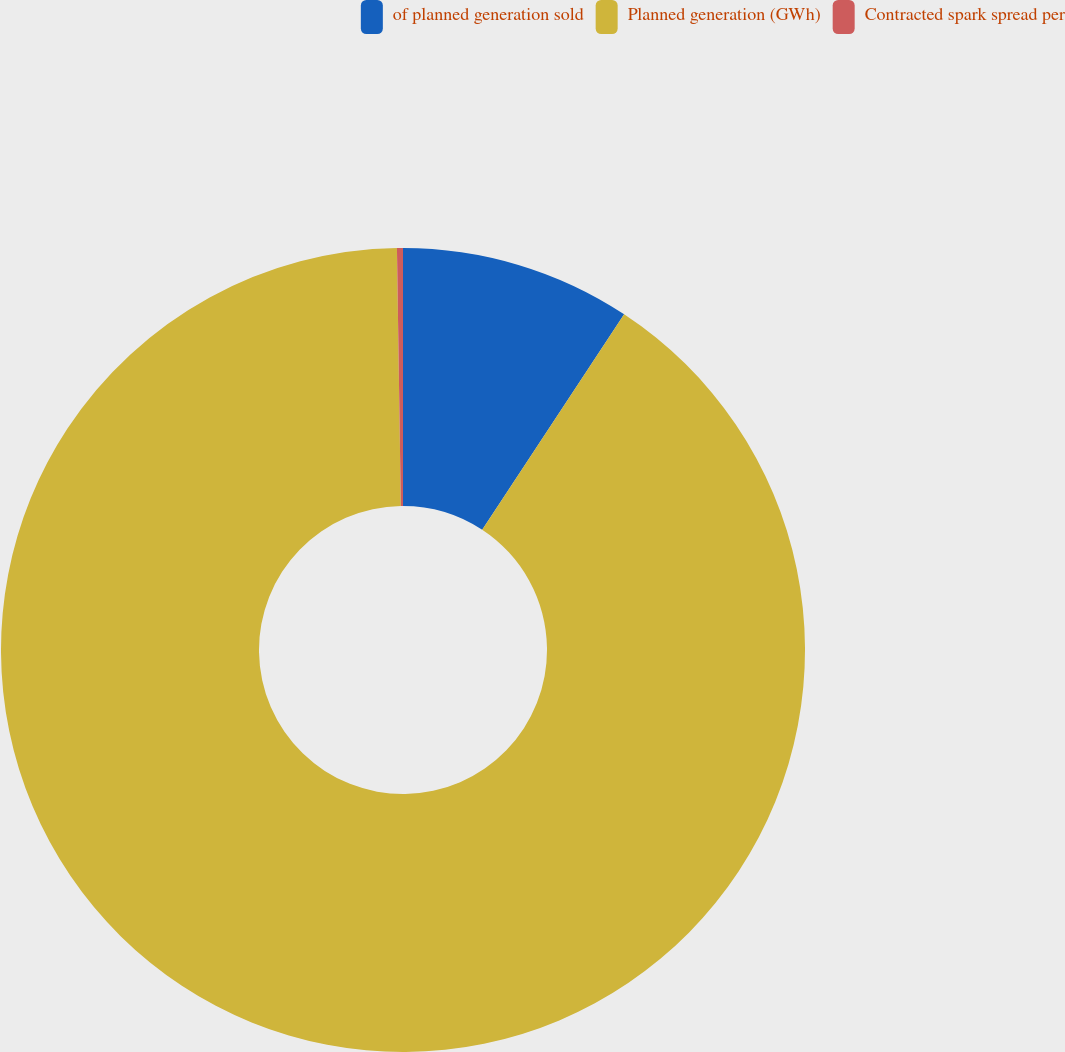Convert chart. <chart><loc_0><loc_0><loc_500><loc_500><pie_chart><fcel>of planned generation sold<fcel>Planned generation (GWh)<fcel>Contracted spark spread per<nl><fcel>9.27%<fcel>90.49%<fcel>0.24%<nl></chart> 